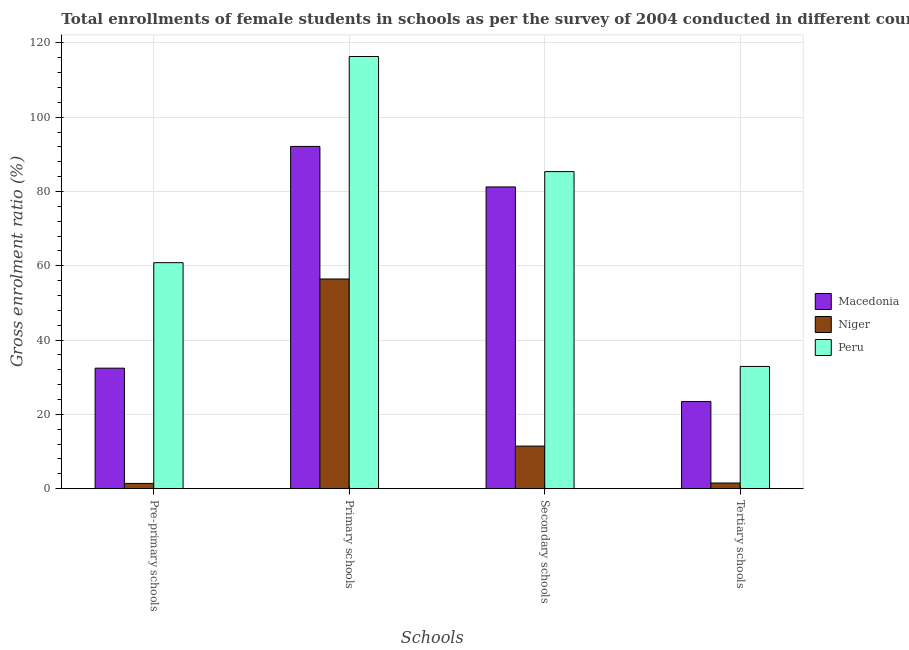Are the number of bars on each tick of the X-axis equal?
Your response must be concise. Yes. How many bars are there on the 1st tick from the left?
Your answer should be very brief. 3. How many bars are there on the 1st tick from the right?
Give a very brief answer. 3. What is the label of the 2nd group of bars from the left?
Provide a succinct answer. Primary schools. What is the gross enrolment ratio(female) in secondary schools in Macedonia?
Your answer should be compact. 81.24. Across all countries, what is the maximum gross enrolment ratio(female) in pre-primary schools?
Your response must be concise. 60.85. Across all countries, what is the minimum gross enrolment ratio(female) in primary schools?
Offer a terse response. 56.45. In which country was the gross enrolment ratio(female) in secondary schools minimum?
Give a very brief answer. Niger. What is the total gross enrolment ratio(female) in secondary schools in the graph?
Offer a very short reply. 178.07. What is the difference between the gross enrolment ratio(female) in primary schools in Macedonia and that in Niger?
Provide a succinct answer. 35.69. What is the difference between the gross enrolment ratio(female) in secondary schools in Peru and the gross enrolment ratio(female) in primary schools in Macedonia?
Provide a short and direct response. -6.78. What is the average gross enrolment ratio(female) in primary schools per country?
Offer a very short reply. 88.32. What is the difference between the gross enrolment ratio(female) in secondary schools and gross enrolment ratio(female) in pre-primary schools in Macedonia?
Offer a terse response. 48.79. What is the ratio of the gross enrolment ratio(female) in secondary schools in Niger to that in Macedonia?
Provide a short and direct response. 0.14. Is the gross enrolment ratio(female) in primary schools in Macedonia less than that in Niger?
Ensure brevity in your answer.  No. What is the difference between the highest and the second highest gross enrolment ratio(female) in pre-primary schools?
Offer a very short reply. 28.4. What is the difference between the highest and the lowest gross enrolment ratio(female) in tertiary schools?
Provide a succinct answer. 31.38. In how many countries, is the gross enrolment ratio(female) in primary schools greater than the average gross enrolment ratio(female) in primary schools taken over all countries?
Your response must be concise. 2. Is it the case that in every country, the sum of the gross enrolment ratio(female) in tertiary schools and gross enrolment ratio(female) in pre-primary schools is greater than the sum of gross enrolment ratio(female) in primary schools and gross enrolment ratio(female) in secondary schools?
Your answer should be very brief. No. What does the 2nd bar from the right in Tertiary schools represents?
Keep it short and to the point. Niger. Is it the case that in every country, the sum of the gross enrolment ratio(female) in pre-primary schools and gross enrolment ratio(female) in primary schools is greater than the gross enrolment ratio(female) in secondary schools?
Offer a very short reply. Yes. How many bars are there?
Your answer should be very brief. 12. Are all the bars in the graph horizontal?
Your answer should be very brief. No. Are the values on the major ticks of Y-axis written in scientific E-notation?
Make the answer very short. No. Does the graph contain grids?
Ensure brevity in your answer.  Yes. What is the title of the graph?
Your response must be concise. Total enrollments of female students in schools as per the survey of 2004 conducted in different countries. Does "Channel Islands" appear as one of the legend labels in the graph?
Ensure brevity in your answer.  No. What is the label or title of the X-axis?
Keep it short and to the point. Schools. What is the label or title of the Y-axis?
Your answer should be compact. Gross enrolment ratio (%). What is the Gross enrolment ratio (%) in Macedonia in Pre-primary schools?
Your answer should be very brief. 32.45. What is the Gross enrolment ratio (%) in Niger in Pre-primary schools?
Provide a succinct answer. 1.42. What is the Gross enrolment ratio (%) of Peru in Pre-primary schools?
Keep it short and to the point. 60.85. What is the Gross enrolment ratio (%) of Macedonia in Primary schools?
Ensure brevity in your answer.  92.15. What is the Gross enrolment ratio (%) of Niger in Primary schools?
Keep it short and to the point. 56.45. What is the Gross enrolment ratio (%) in Peru in Primary schools?
Your response must be concise. 116.36. What is the Gross enrolment ratio (%) in Macedonia in Secondary schools?
Offer a terse response. 81.24. What is the Gross enrolment ratio (%) in Niger in Secondary schools?
Keep it short and to the point. 11.47. What is the Gross enrolment ratio (%) in Peru in Secondary schools?
Your answer should be compact. 85.37. What is the Gross enrolment ratio (%) in Macedonia in Tertiary schools?
Your response must be concise. 23.46. What is the Gross enrolment ratio (%) in Niger in Tertiary schools?
Offer a very short reply. 1.52. What is the Gross enrolment ratio (%) of Peru in Tertiary schools?
Your answer should be very brief. 32.91. Across all Schools, what is the maximum Gross enrolment ratio (%) of Macedonia?
Ensure brevity in your answer.  92.15. Across all Schools, what is the maximum Gross enrolment ratio (%) in Niger?
Make the answer very short. 56.45. Across all Schools, what is the maximum Gross enrolment ratio (%) in Peru?
Provide a succinct answer. 116.36. Across all Schools, what is the minimum Gross enrolment ratio (%) in Macedonia?
Make the answer very short. 23.46. Across all Schools, what is the minimum Gross enrolment ratio (%) of Niger?
Make the answer very short. 1.42. Across all Schools, what is the minimum Gross enrolment ratio (%) of Peru?
Offer a very short reply. 32.91. What is the total Gross enrolment ratio (%) of Macedonia in the graph?
Offer a terse response. 229.3. What is the total Gross enrolment ratio (%) in Niger in the graph?
Provide a short and direct response. 70.86. What is the total Gross enrolment ratio (%) of Peru in the graph?
Give a very brief answer. 295.48. What is the difference between the Gross enrolment ratio (%) of Macedonia in Pre-primary schools and that in Primary schools?
Your answer should be compact. -59.7. What is the difference between the Gross enrolment ratio (%) in Niger in Pre-primary schools and that in Primary schools?
Give a very brief answer. -55.04. What is the difference between the Gross enrolment ratio (%) in Peru in Pre-primary schools and that in Primary schools?
Provide a succinct answer. -55.51. What is the difference between the Gross enrolment ratio (%) of Macedonia in Pre-primary schools and that in Secondary schools?
Your answer should be very brief. -48.79. What is the difference between the Gross enrolment ratio (%) in Niger in Pre-primary schools and that in Secondary schools?
Your response must be concise. -10.05. What is the difference between the Gross enrolment ratio (%) of Peru in Pre-primary schools and that in Secondary schools?
Keep it short and to the point. -24.52. What is the difference between the Gross enrolment ratio (%) of Macedonia in Pre-primary schools and that in Tertiary schools?
Make the answer very short. 8.99. What is the difference between the Gross enrolment ratio (%) in Niger in Pre-primary schools and that in Tertiary schools?
Your response must be concise. -0.11. What is the difference between the Gross enrolment ratio (%) in Peru in Pre-primary schools and that in Tertiary schools?
Offer a very short reply. 27.94. What is the difference between the Gross enrolment ratio (%) in Macedonia in Primary schools and that in Secondary schools?
Your answer should be compact. 10.91. What is the difference between the Gross enrolment ratio (%) in Niger in Primary schools and that in Secondary schools?
Offer a very short reply. 44.99. What is the difference between the Gross enrolment ratio (%) of Peru in Primary schools and that in Secondary schools?
Offer a terse response. 30.99. What is the difference between the Gross enrolment ratio (%) in Macedonia in Primary schools and that in Tertiary schools?
Provide a succinct answer. 68.69. What is the difference between the Gross enrolment ratio (%) of Niger in Primary schools and that in Tertiary schools?
Your answer should be compact. 54.93. What is the difference between the Gross enrolment ratio (%) in Peru in Primary schools and that in Tertiary schools?
Your answer should be very brief. 83.45. What is the difference between the Gross enrolment ratio (%) in Macedonia in Secondary schools and that in Tertiary schools?
Provide a succinct answer. 57.78. What is the difference between the Gross enrolment ratio (%) in Niger in Secondary schools and that in Tertiary schools?
Offer a very short reply. 9.94. What is the difference between the Gross enrolment ratio (%) in Peru in Secondary schools and that in Tertiary schools?
Make the answer very short. 52.46. What is the difference between the Gross enrolment ratio (%) of Macedonia in Pre-primary schools and the Gross enrolment ratio (%) of Niger in Primary schools?
Keep it short and to the point. -24.01. What is the difference between the Gross enrolment ratio (%) in Macedonia in Pre-primary schools and the Gross enrolment ratio (%) in Peru in Primary schools?
Make the answer very short. -83.91. What is the difference between the Gross enrolment ratio (%) of Niger in Pre-primary schools and the Gross enrolment ratio (%) of Peru in Primary schools?
Offer a terse response. -114.94. What is the difference between the Gross enrolment ratio (%) of Macedonia in Pre-primary schools and the Gross enrolment ratio (%) of Niger in Secondary schools?
Your answer should be compact. 20.98. What is the difference between the Gross enrolment ratio (%) of Macedonia in Pre-primary schools and the Gross enrolment ratio (%) of Peru in Secondary schools?
Keep it short and to the point. -52.92. What is the difference between the Gross enrolment ratio (%) of Niger in Pre-primary schools and the Gross enrolment ratio (%) of Peru in Secondary schools?
Offer a very short reply. -83.95. What is the difference between the Gross enrolment ratio (%) of Macedonia in Pre-primary schools and the Gross enrolment ratio (%) of Niger in Tertiary schools?
Your response must be concise. 30.92. What is the difference between the Gross enrolment ratio (%) in Macedonia in Pre-primary schools and the Gross enrolment ratio (%) in Peru in Tertiary schools?
Offer a terse response. -0.46. What is the difference between the Gross enrolment ratio (%) in Niger in Pre-primary schools and the Gross enrolment ratio (%) in Peru in Tertiary schools?
Offer a terse response. -31.49. What is the difference between the Gross enrolment ratio (%) in Macedonia in Primary schools and the Gross enrolment ratio (%) in Niger in Secondary schools?
Your answer should be very brief. 80.68. What is the difference between the Gross enrolment ratio (%) of Macedonia in Primary schools and the Gross enrolment ratio (%) of Peru in Secondary schools?
Keep it short and to the point. 6.78. What is the difference between the Gross enrolment ratio (%) of Niger in Primary schools and the Gross enrolment ratio (%) of Peru in Secondary schools?
Provide a short and direct response. -28.91. What is the difference between the Gross enrolment ratio (%) of Macedonia in Primary schools and the Gross enrolment ratio (%) of Niger in Tertiary schools?
Your answer should be very brief. 90.62. What is the difference between the Gross enrolment ratio (%) in Macedonia in Primary schools and the Gross enrolment ratio (%) in Peru in Tertiary schools?
Your answer should be very brief. 59.24. What is the difference between the Gross enrolment ratio (%) of Niger in Primary schools and the Gross enrolment ratio (%) of Peru in Tertiary schools?
Ensure brevity in your answer.  23.55. What is the difference between the Gross enrolment ratio (%) of Macedonia in Secondary schools and the Gross enrolment ratio (%) of Niger in Tertiary schools?
Provide a succinct answer. 79.71. What is the difference between the Gross enrolment ratio (%) of Macedonia in Secondary schools and the Gross enrolment ratio (%) of Peru in Tertiary schools?
Your response must be concise. 48.33. What is the difference between the Gross enrolment ratio (%) of Niger in Secondary schools and the Gross enrolment ratio (%) of Peru in Tertiary schools?
Offer a terse response. -21.44. What is the average Gross enrolment ratio (%) in Macedonia per Schools?
Provide a short and direct response. 57.32. What is the average Gross enrolment ratio (%) of Niger per Schools?
Your answer should be very brief. 17.72. What is the average Gross enrolment ratio (%) of Peru per Schools?
Provide a succinct answer. 73.87. What is the difference between the Gross enrolment ratio (%) in Macedonia and Gross enrolment ratio (%) in Niger in Pre-primary schools?
Your answer should be compact. 31.03. What is the difference between the Gross enrolment ratio (%) of Macedonia and Gross enrolment ratio (%) of Peru in Pre-primary schools?
Offer a terse response. -28.4. What is the difference between the Gross enrolment ratio (%) in Niger and Gross enrolment ratio (%) in Peru in Pre-primary schools?
Provide a short and direct response. -59.43. What is the difference between the Gross enrolment ratio (%) in Macedonia and Gross enrolment ratio (%) in Niger in Primary schools?
Your answer should be very brief. 35.69. What is the difference between the Gross enrolment ratio (%) of Macedonia and Gross enrolment ratio (%) of Peru in Primary schools?
Provide a short and direct response. -24.21. What is the difference between the Gross enrolment ratio (%) of Niger and Gross enrolment ratio (%) of Peru in Primary schools?
Offer a terse response. -59.9. What is the difference between the Gross enrolment ratio (%) in Macedonia and Gross enrolment ratio (%) in Niger in Secondary schools?
Make the answer very short. 69.77. What is the difference between the Gross enrolment ratio (%) in Macedonia and Gross enrolment ratio (%) in Peru in Secondary schools?
Your answer should be compact. -4.13. What is the difference between the Gross enrolment ratio (%) in Niger and Gross enrolment ratio (%) in Peru in Secondary schools?
Offer a terse response. -73.9. What is the difference between the Gross enrolment ratio (%) in Macedonia and Gross enrolment ratio (%) in Niger in Tertiary schools?
Provide a succinct answer. 21.94. What is the difference between the Gross enrolment ratio (%) of Macedonia and Gross enrolment ratio (%) of Peru in Tertiary schools?
Offer a terse response. -9.45. What is the difference between the Gross enrolment ratio (%) in Niger and Gross enrolment ratio (%) in Peru in Tertiary schools?
Provide a short and direct response. -31.38. What is the ratio of the Gross enrolment ratio (%) of Macedonia in Pre-primary schools to that in Primary schools?
Give a very brief answer. 0.35. What is the ratio of the Gross enrolment ratio (%) of Niger in Pre-primary schools to that in Primary schools?
Provide a succinct answer. 0.03. What is the ratio of the Gross enrolment ratio (%) in Peru in Pre-primary schools to that in Primary schools?
Ensure brevity in your answer.  0.52. What is the ratio of the Gross enrolment ratio (%) of Macedonia in Pre-primary schools to that in Secondary schools?
Offer a terse response. 0.4. What is the ratio of the Gross enrolment ratio (%) in Niger in Pre-primary schools to that in Secondary schools?
Give a very brief answer. 0.12. What is the ratio of the Gross enrolment ratio (%) in Peru in Pre-primary schools to that in Secondary schools?
Ensure brevity in your answer.  0.71. What is the ratio of the Gross enrolment ratio (%) of Macedonia in Pre-primary schools to that in Tertiary schools?
Provide a short and direct response. 1.38. What is the ratio of the Gross enrolment ratio (%) of Niger in Pre-primary schools to that in Tertiary schools?
Keep it short and to the point. 0.93. What is the ratio of the Gross enrolment ratio (%) in Peru in Pre-primary schools to that in Tertiary schools?
Ensure brevity in your answer.  1.85. What is the ratio of the Gross enrolment ratio (%) of Macedonia in Primary schools to that in Secondary schools?
Offer a very short reply. 1.13. What is the ratio of the Gross enrolment ratio (%) of Niger in Primary schools to that in Secondary schools?
Provide a short and direct response. 4.92. What is the ratio of the Gross enrolment ratio (%) of Peru in Primary schools to that in Secondary schools?
Keep it short and to the point. 1.36. What is the ratio of the Gross enrolment ratio (%) of Macedonia in Primary schools to that in Tertiary schools?
Your answer should be compact. 3.93. What is the ratio of the Gross enrolment ratio (%) in Niger in Primary schools to that in Tertiary schools?
Make the answer very short. 37.02. What is the ratio of the Gross enrolment ratio (%) in Peru in Primary schools to that in Tertiary schools?
Your response must be concise. 3.54. What is the ratio of the Gross enrolment ratio (%) in Macedonia in Secondary schools to that in Tertiary schools?
Provide a short and direct response. 3.46. What is the ratio of the Gross enrolment ratio (%) of Niger in Secondary schools to that in Tertiary schools?
Make the answer very short. 7.52. What is the ratio of the Gross enrolment ratio (%) in Peru in Secondary schools to that in Tertiary schools?
Provide a succinct answer. 2.59. What is the difference between the highest and the second highest Gross enrolment ratio (%) in Macedonia?
Keep it short and to the point. 10.91. What is the difference between the highest and the second highest Gross enrolment ratio (%) in Niger?
Provide a succinct answer. 44.99. What is the difference between the highest and the second highest Gross enrolment ratio (%) of Peru?
Provide a short and direct response. 30.99. What is the difference between the highest and the lowest Gross enrolment ratio (%) of Macedonia?
Ensure brevity in your answer.  68.69. What is the difference between the highest and the lowest Gross enrolment ratio (%) of Niger?
Give a very brief answer. 55.04. What is the difference between the highest and the lowest Gross enrolment ratio (%) of Peru?
Your answer should be very brief. 83.45. 